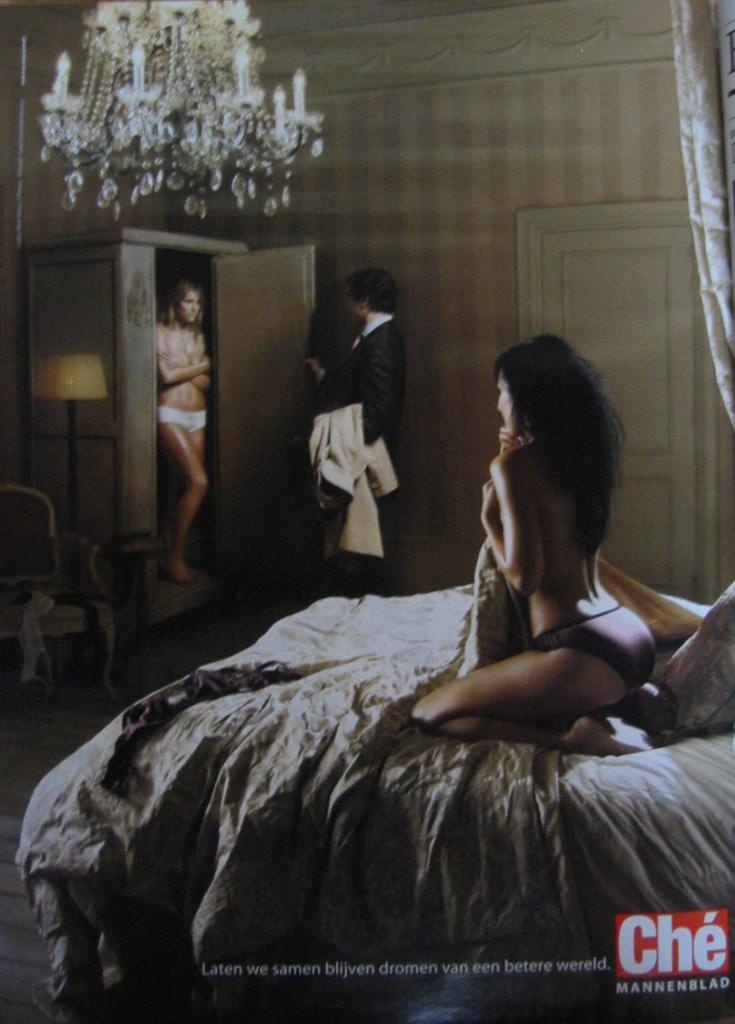How many people are present in the image? There are three people in the image. What are the positions of the people in the image? Two of the people are standing, and one person is sitting on a bed. What objects can be seen in the image besides the people? There is a lamp and a curtain in the image. What type of trucks can be seen driving through the snow in the image? There are no trucks or snow present in the image; it features three people, a lamp, and a curtain. How does the sail affect the position of the people in the image? There is no sail present in the image, so it cannot affect the position of the people. 